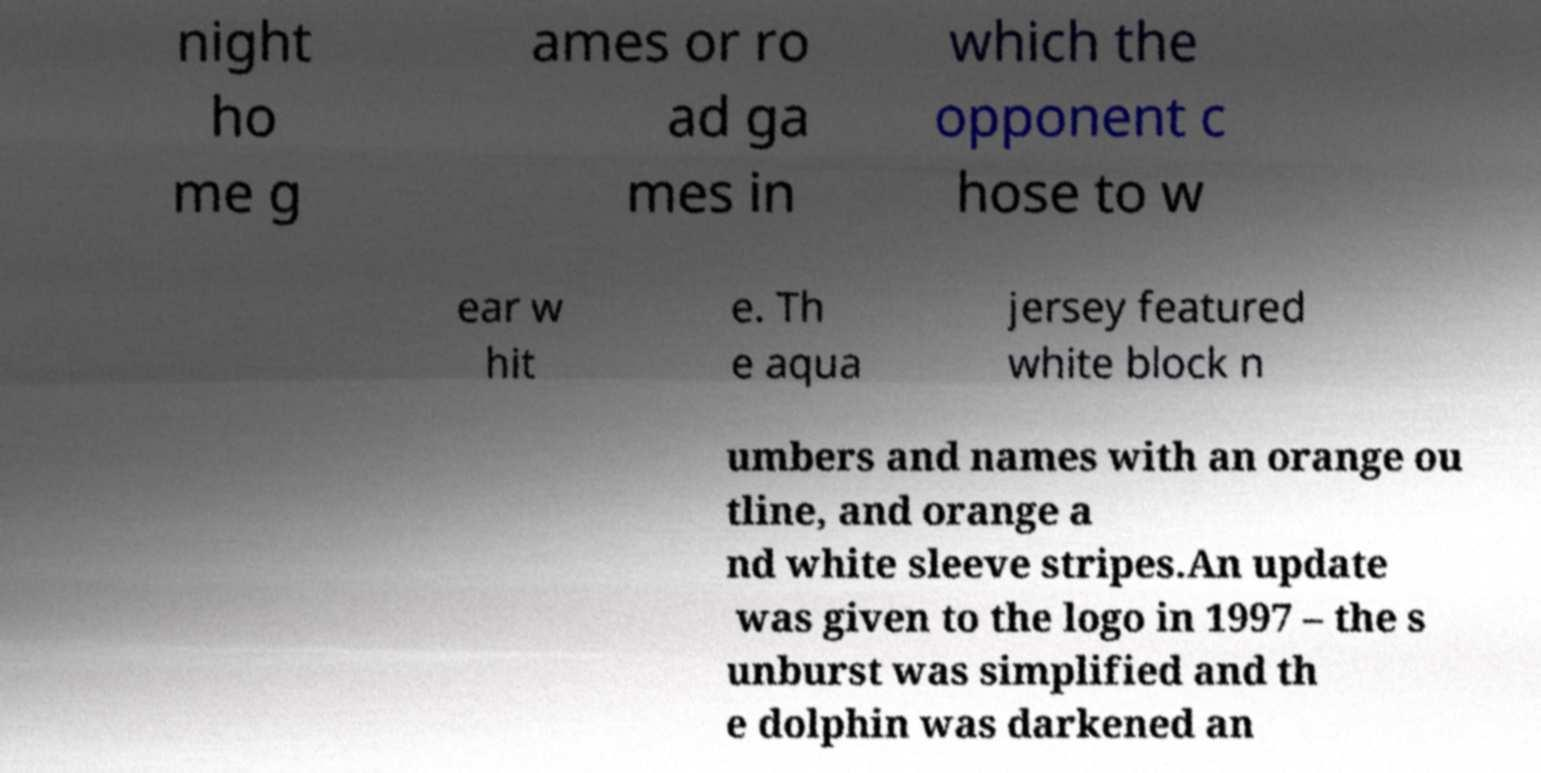Could you assist in decoding the text presented in this image and type it out clearly? night ho me g ames or ro ad ga mes in which the opponent c hose to w ear w hit e. Th e aqua jersey featured white block n umbers and names with an orange ou tline, and orange a nd white sleeve stripes.An update was given to the logo in 1997 – the s unburst was simplified and th e dolphin was darkened an 